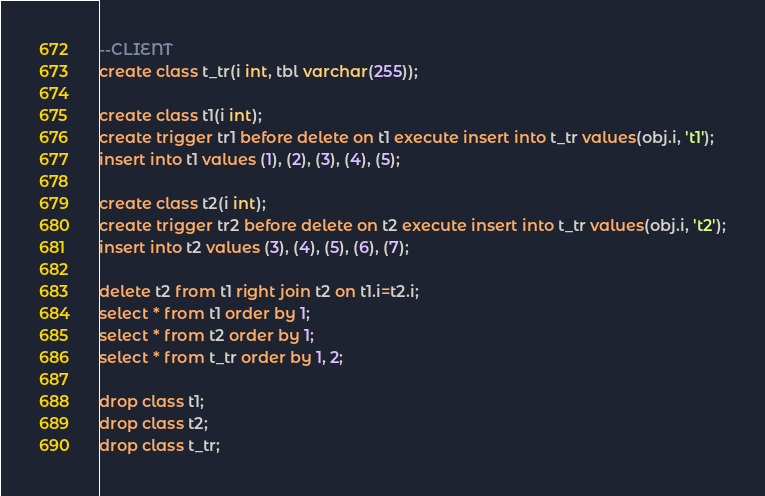<code> <loc_0><loc_0><loc_500><loc_500><_SQL_>--CLIENT
create class t_tr(i int, tbl varchar(255));

create class t1(i int);
create trigger tr1 before delete on t1 execute insert into t_tr values(obj.i, 't1');
insert into t1 values (1), (2), (3), (4), (5);

create class t2(i int);
create trigger tr2 before delete on t2 execute insert into t_tr values(obj.i, 't2');
insert into t2 values (3), (4), (5), (6), (7);

delete t2 from t1 right join t2 on t1.i=t2.i;
select * from t1 order by 1;
select * from t2 order by 1;
select * from t_tr order by 1, 2;

drop class t1;
drop class t2;
drop class t_tr;</code> 